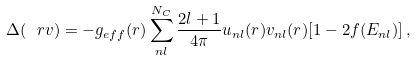Convert formula to latex. <formula><loc_0><loc_0><loc_500><loc_500>\Delta ( \ r v ) = - g _ { e f f } ( r ) \sum _ { n l } ^ { N _ { C } } \frac { 2 l + 1 } { 4 \pi } u _ { n l } ( r ) v _ { n l } ( r ) [ 1 - 2 f ( E _ { n l } ) ] \, ,</formula> 